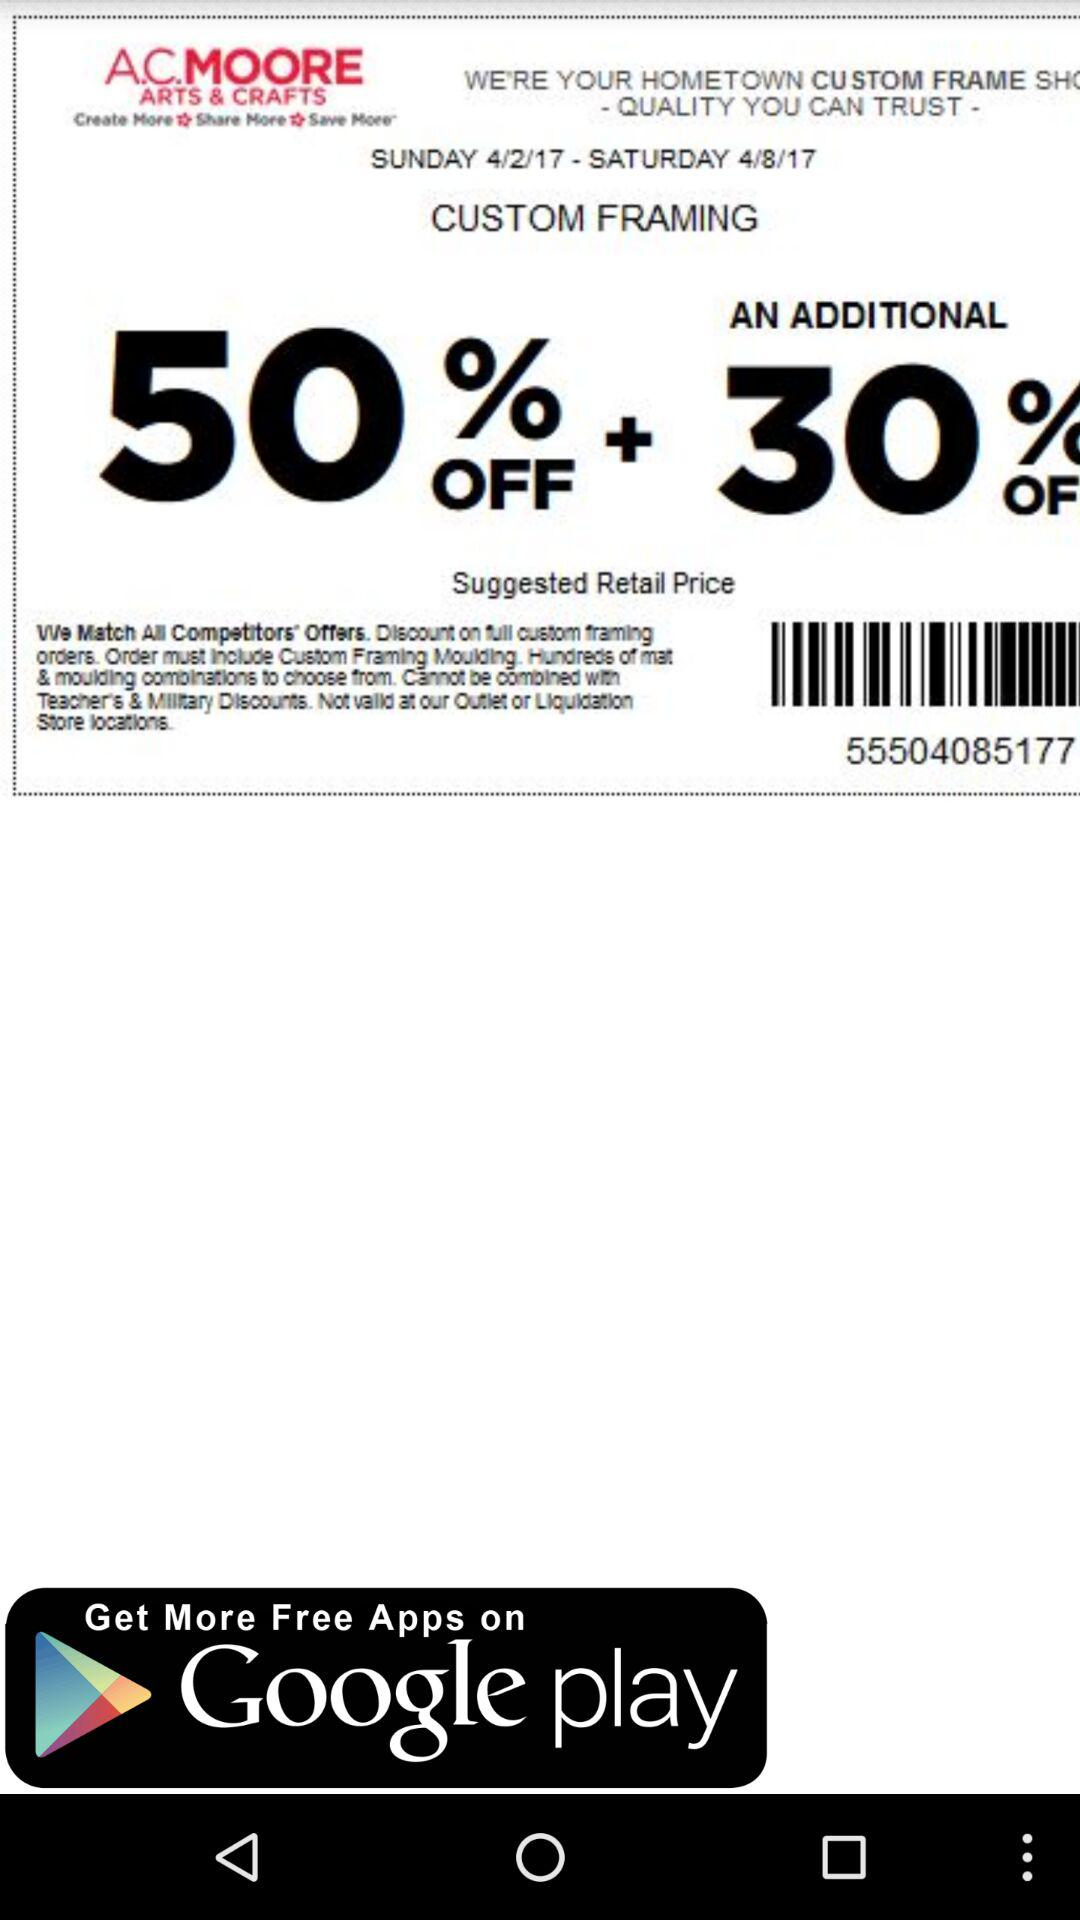How much additional discount is there? There is an additional discount of 30%. 